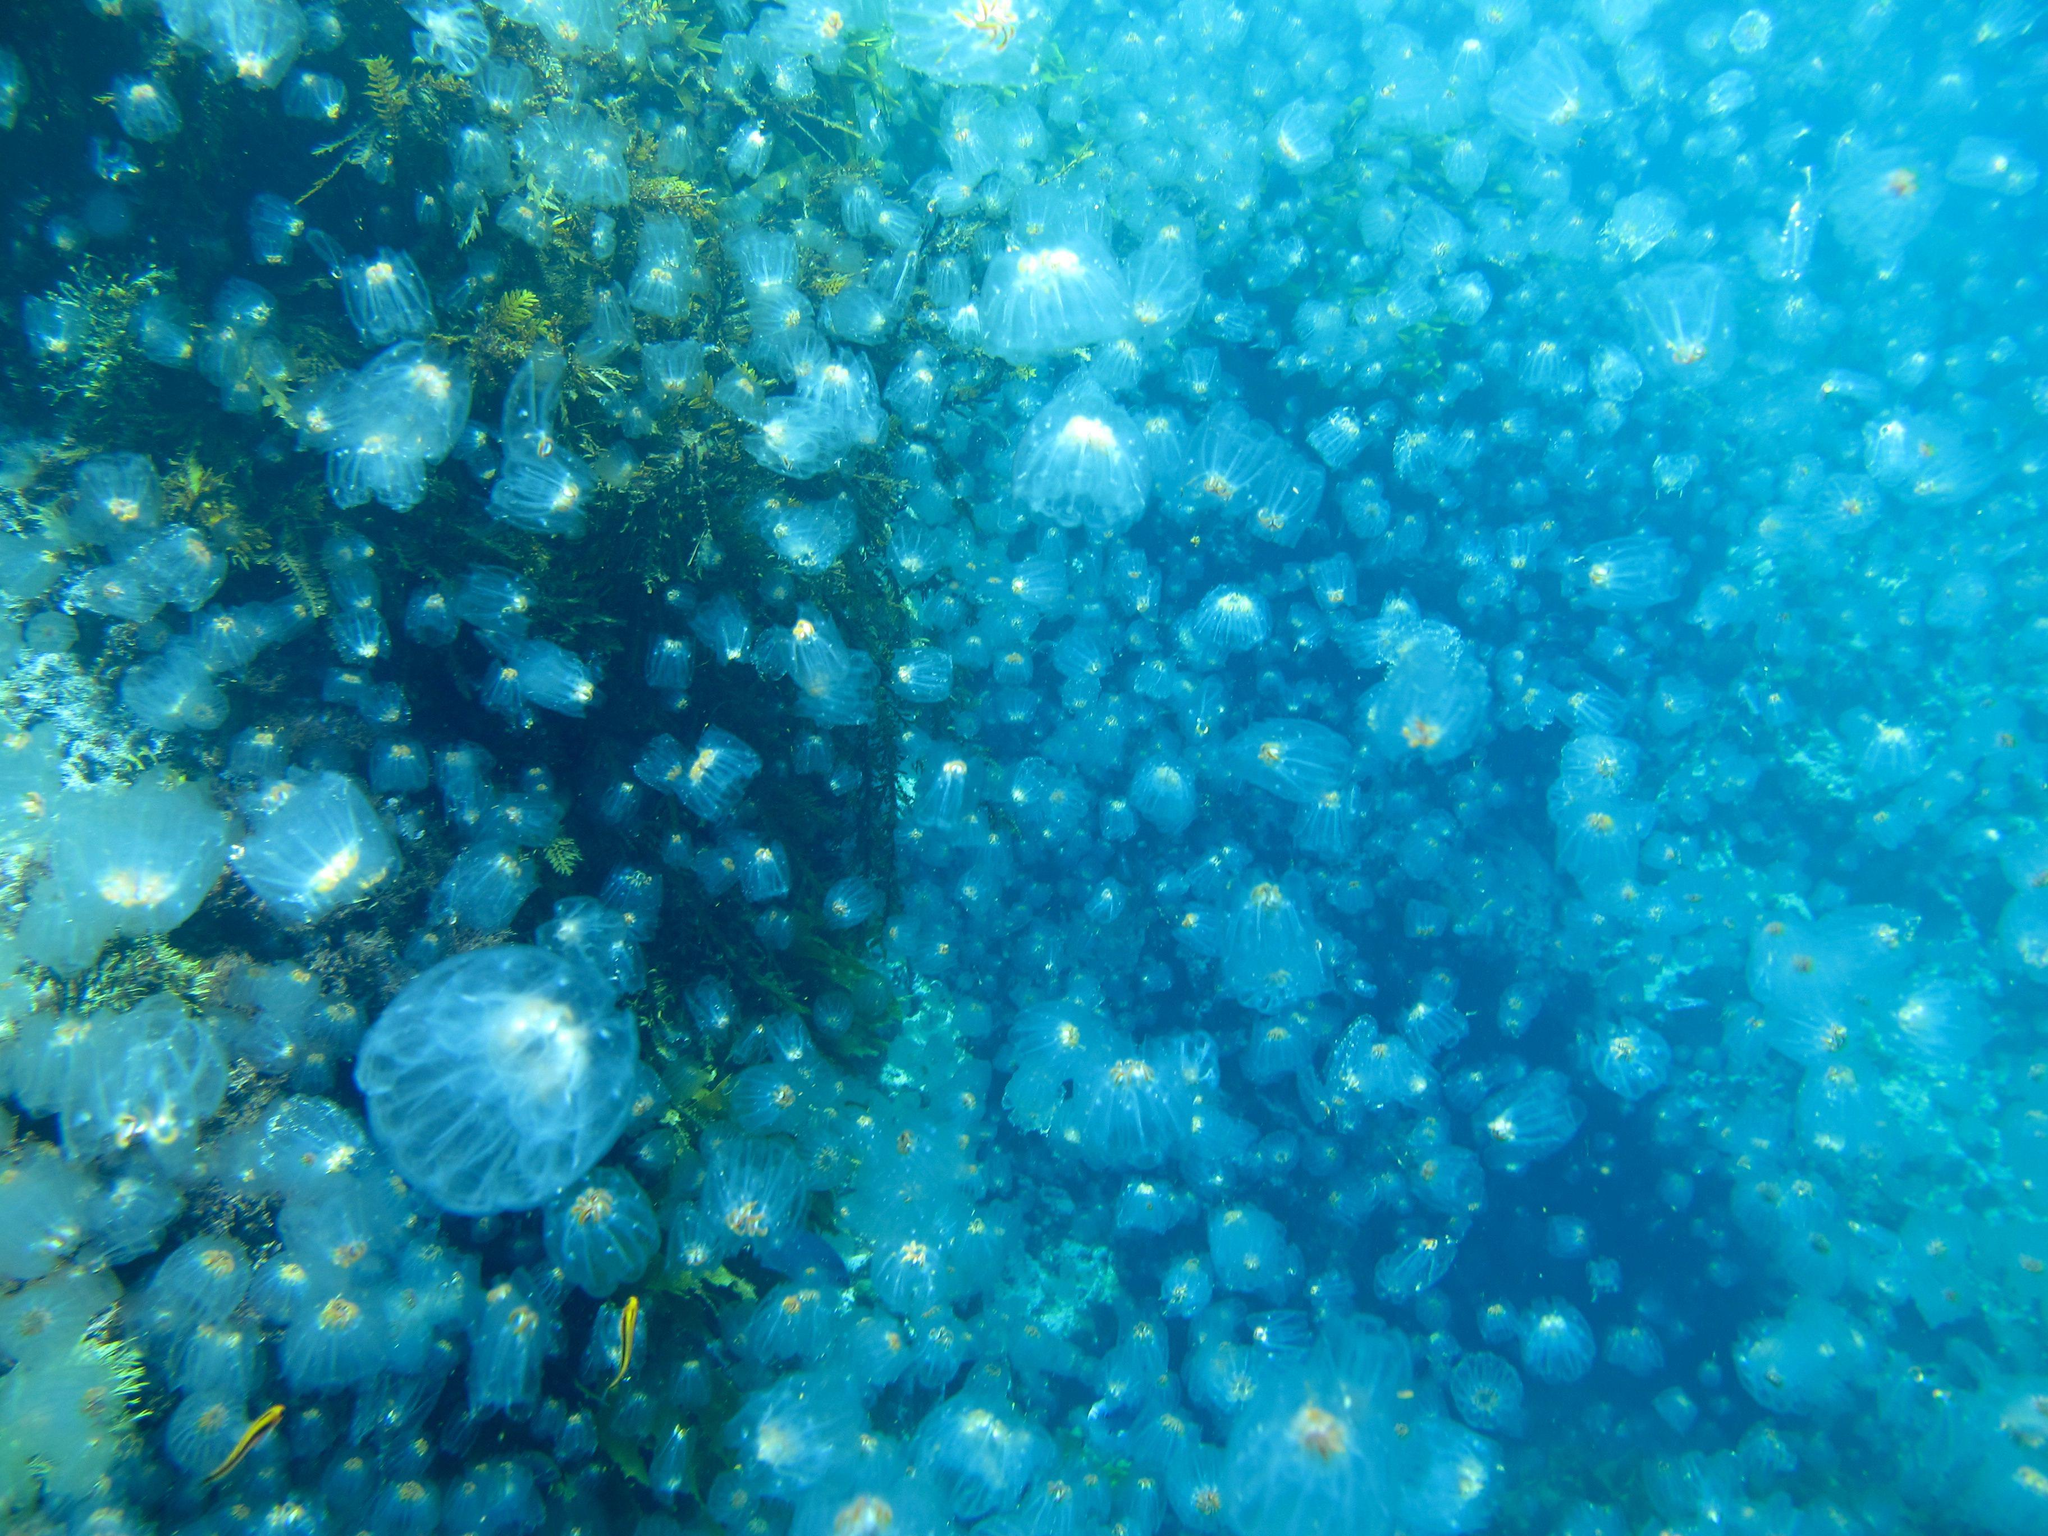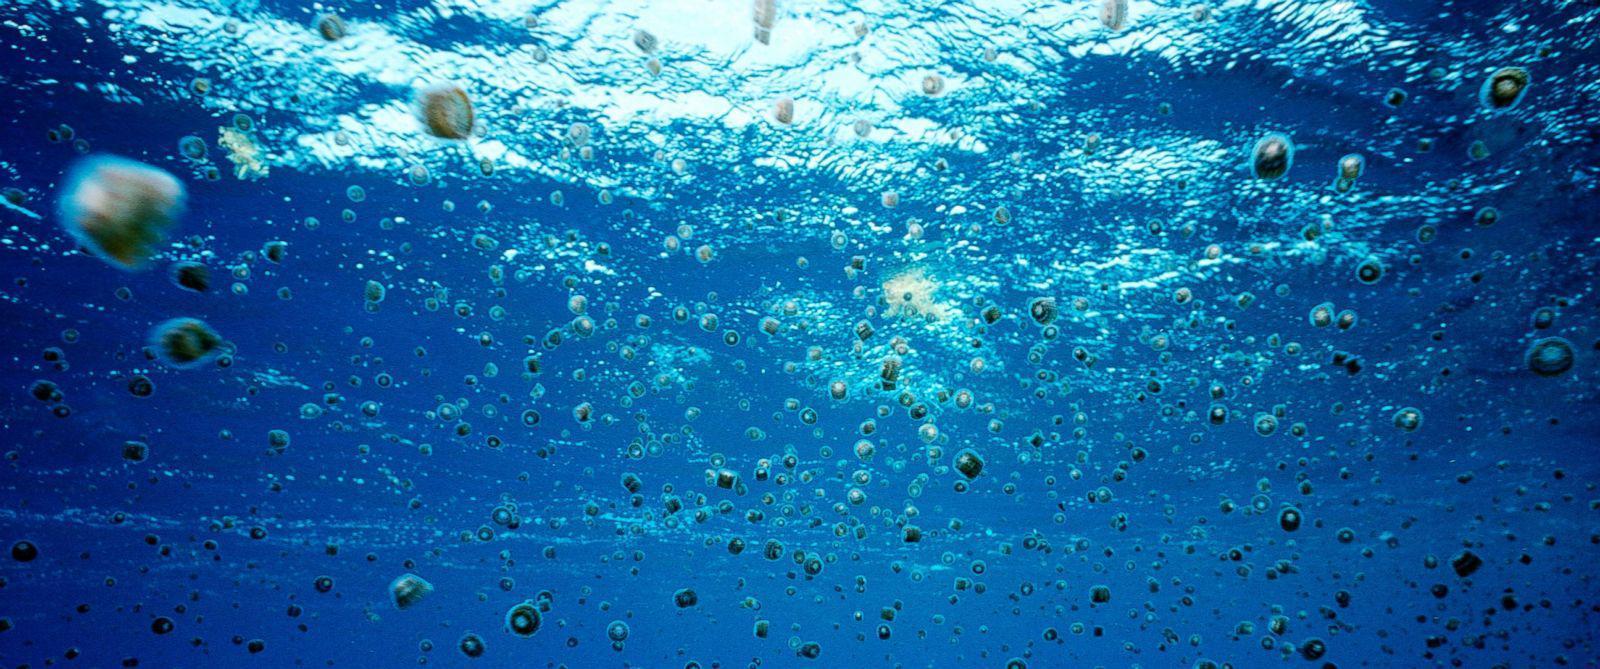The first image is the image on the left, the second image is the image on the right. For the images displayed, is the sentence "One photo shows a large group of yellow-tinted jellyfish." factually correct? Answer yes or no. No. 